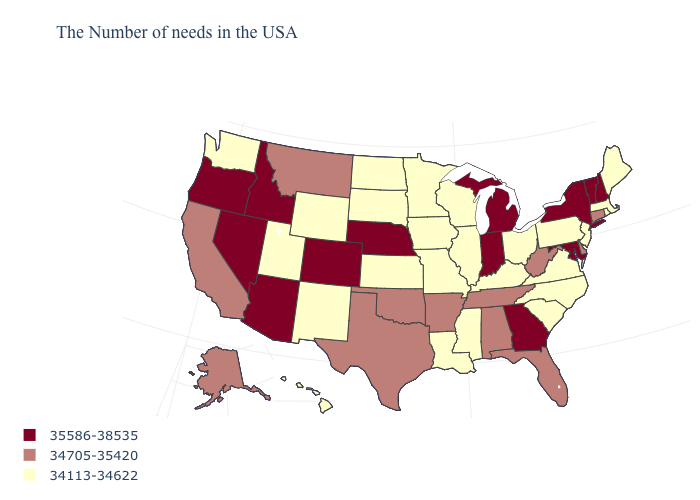Name the states that have a value in the range 34113-34622?
Keep it brief. Maine, Massachusetts, Rhode Island, New Jersey, Pennsylvania, Virginia, North Carolina, South Carolina, Ohio, Kentucky, Wisconsin, Illinois, Mississippi, Louisiana, Missouri, Minnesota, Iowa, Kansas, South Dakota, North Dakota, Wyoming, New Mexico, Utah, Washington, Hawaii. Name the states that have a value in the range 34113-34622?
Write a very short answer. Maine, Massachusetts, Rhode Island, New Jersey, Pennsylvania, Virginia, North Carolina, South Carolina, Ohio, Kentucky, Wisconsin, Illinois, Mississippi, Louisiana, Missouri, Minnesota, Iowa, Kansas, South Dakota, North Dakota, Wyoming, New Mexico, Utah, Washington, Hawaii. Does New Hampshire have the highest value in the Northeast?
Concise answer only. Yes. Does the map have missing data?
Answer briefly. No. Does Pennsylvania have a lower value than Oregon?
Answer briefly. Yes. Does Massachusetts have a higher value than Oregon?
Quick response, please. No. Does Arkansas have the highest value in the USA?
Short answer required. No. Does the map have missing data?
Short answer required. No. Name the states that have a value in the range 34113-34622?
Give a very brief answer. Maine, Massachusetts, Rhode Island, New Jersey, Pennsylvania, Virginia, North Carolina, South Carolina, Ohio, Kentucky, Wisconsin, Illinois, Mississippi, Louisiana, Missouri, Minnesota, Iowa, Kansas, South Dakota, North Dakota, Wyoming, New Mexico, Utah, Washington, Hawaii. Name the states that have a value in the range 34113-34622?
Quick response, please. Maine, Massachusetts, Rhode Island, New Jersey, Pennsylvania, Virginia, North Carolina, South Carolina, Ohio, Kentucky, Wisconsin, Illinois, Mississippi, Louisiana, Missouri, Minnesota, Iowa, Kansas, South Dakota, North Dakota, Wyoming, New Mexico, Utah, Washington, Hawaii. What is the highest value in the Northeast ?
Concise answer only. 35586-38535. What is the value of Washington?
Write a very short answer. 34113-34622. Name the states that have a value in the range 34113-34622?
Short answer required. Maine, Massachusetts, Rhode Island, New Jersey, Pennsylvania, Virginia, North Carolina, South Carolina, Ohio, Kentucky, Wisconsin, Illinois, Mississippi, Louisiana, Missouri, Minnesota, Iowa, Kansas, South Dakota, North Dakota, Wyoming, New Mexico, Utah, Washington, Hawaii. Name the states that have a value in the range 34705-35420?
Write a very short answer. Connecticut, Delaware, West Virginia, Florida, Alabama, Tennessee, Arkansas, Oklahoma, Texas, Montana, California, Alaska. 